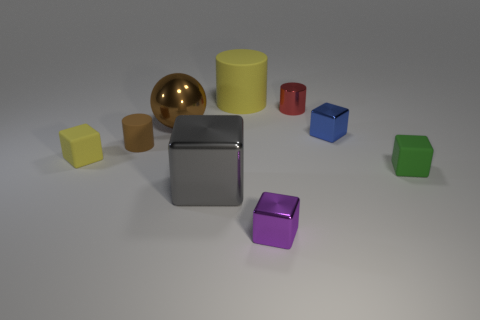Subtract all yellow blocks. How many blocks are left? 4 Subtract all tiny yellow rubber blocks. How many blocks are left? 4 Subtract all brown cubes. Subtract all brown cylinders. How many cubes are left? 5 Add 1 tiny brown spheres. How many objects exist? 10 Subtract all blocks. How many objects are left? 4 Add 6 yellow matte blocks. How many yellow matte blocks are left? 7 Add 8 shiny cylinders. How many shiny cylinders exist? 9 Subtract 0 brown cubes. How many objects are left? 9 Subtract all small brown matte objects. Subtract all green rubber objects. How many objects are left? 7 